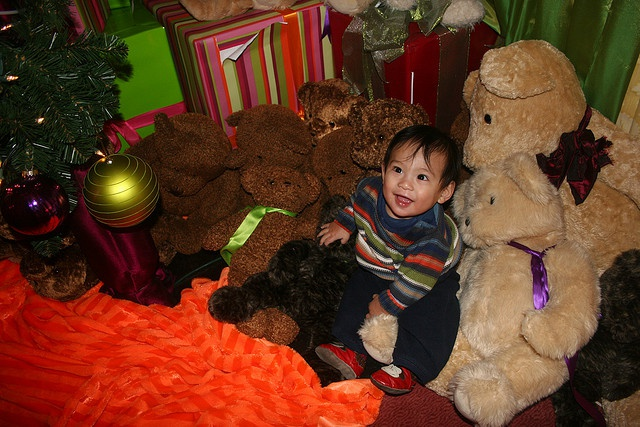Describe the objects in this image and their specific colors. I can see teddy bear in black, tan, gray, and brown tones, people in black, brown, maroon, and olive tones, teddy bear in black, gray, brown, and maroon tones, teddy bear in black, maroon, and red tones, and teddy bear in black, maroon, darkgreen, and olive tones in this image. 